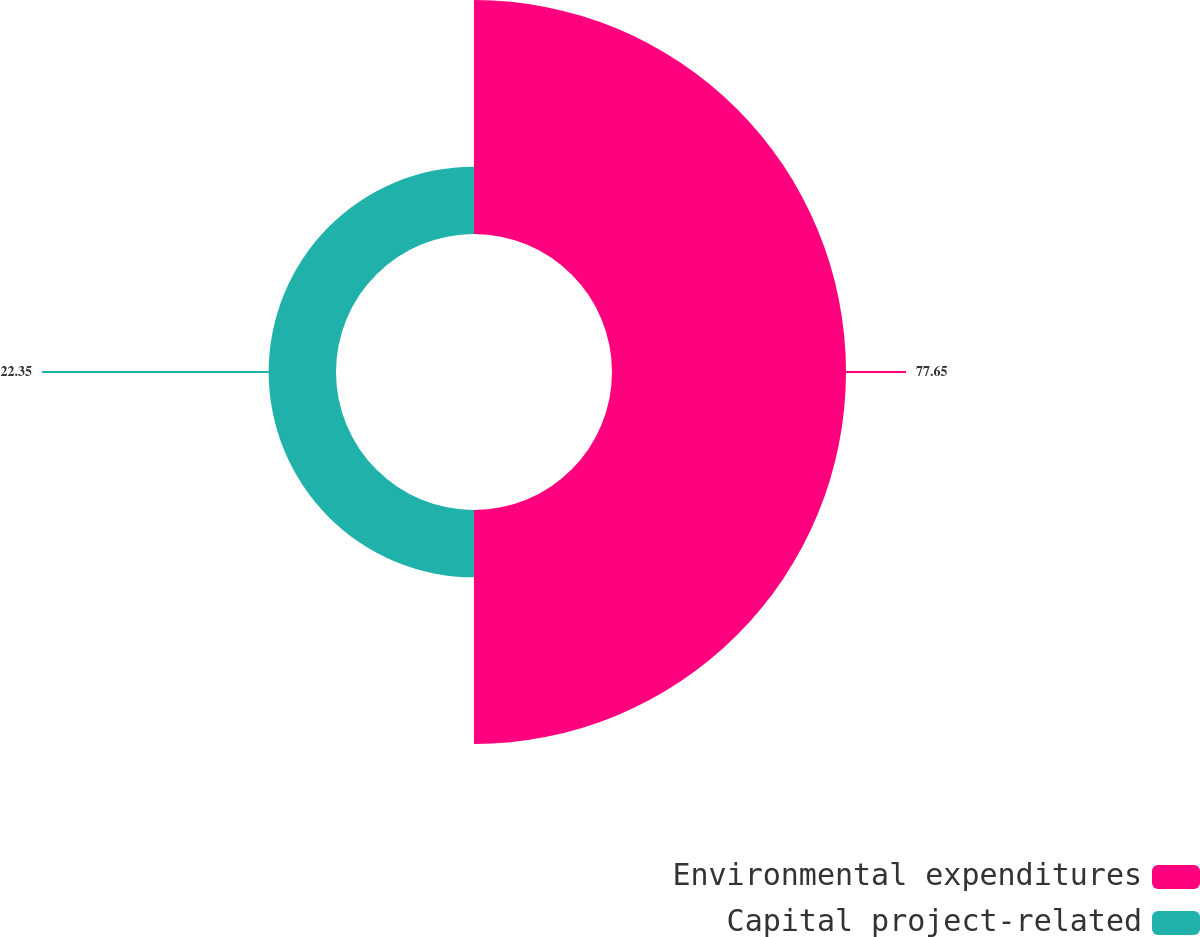<chart> <loc_0><loc_0><loc_500><loc_500><pie_chart><fcel>Environmental expenditures<fcel>Capital project-related<nl><fcel>77.65%<fcel>22.35%<nl></chart> 